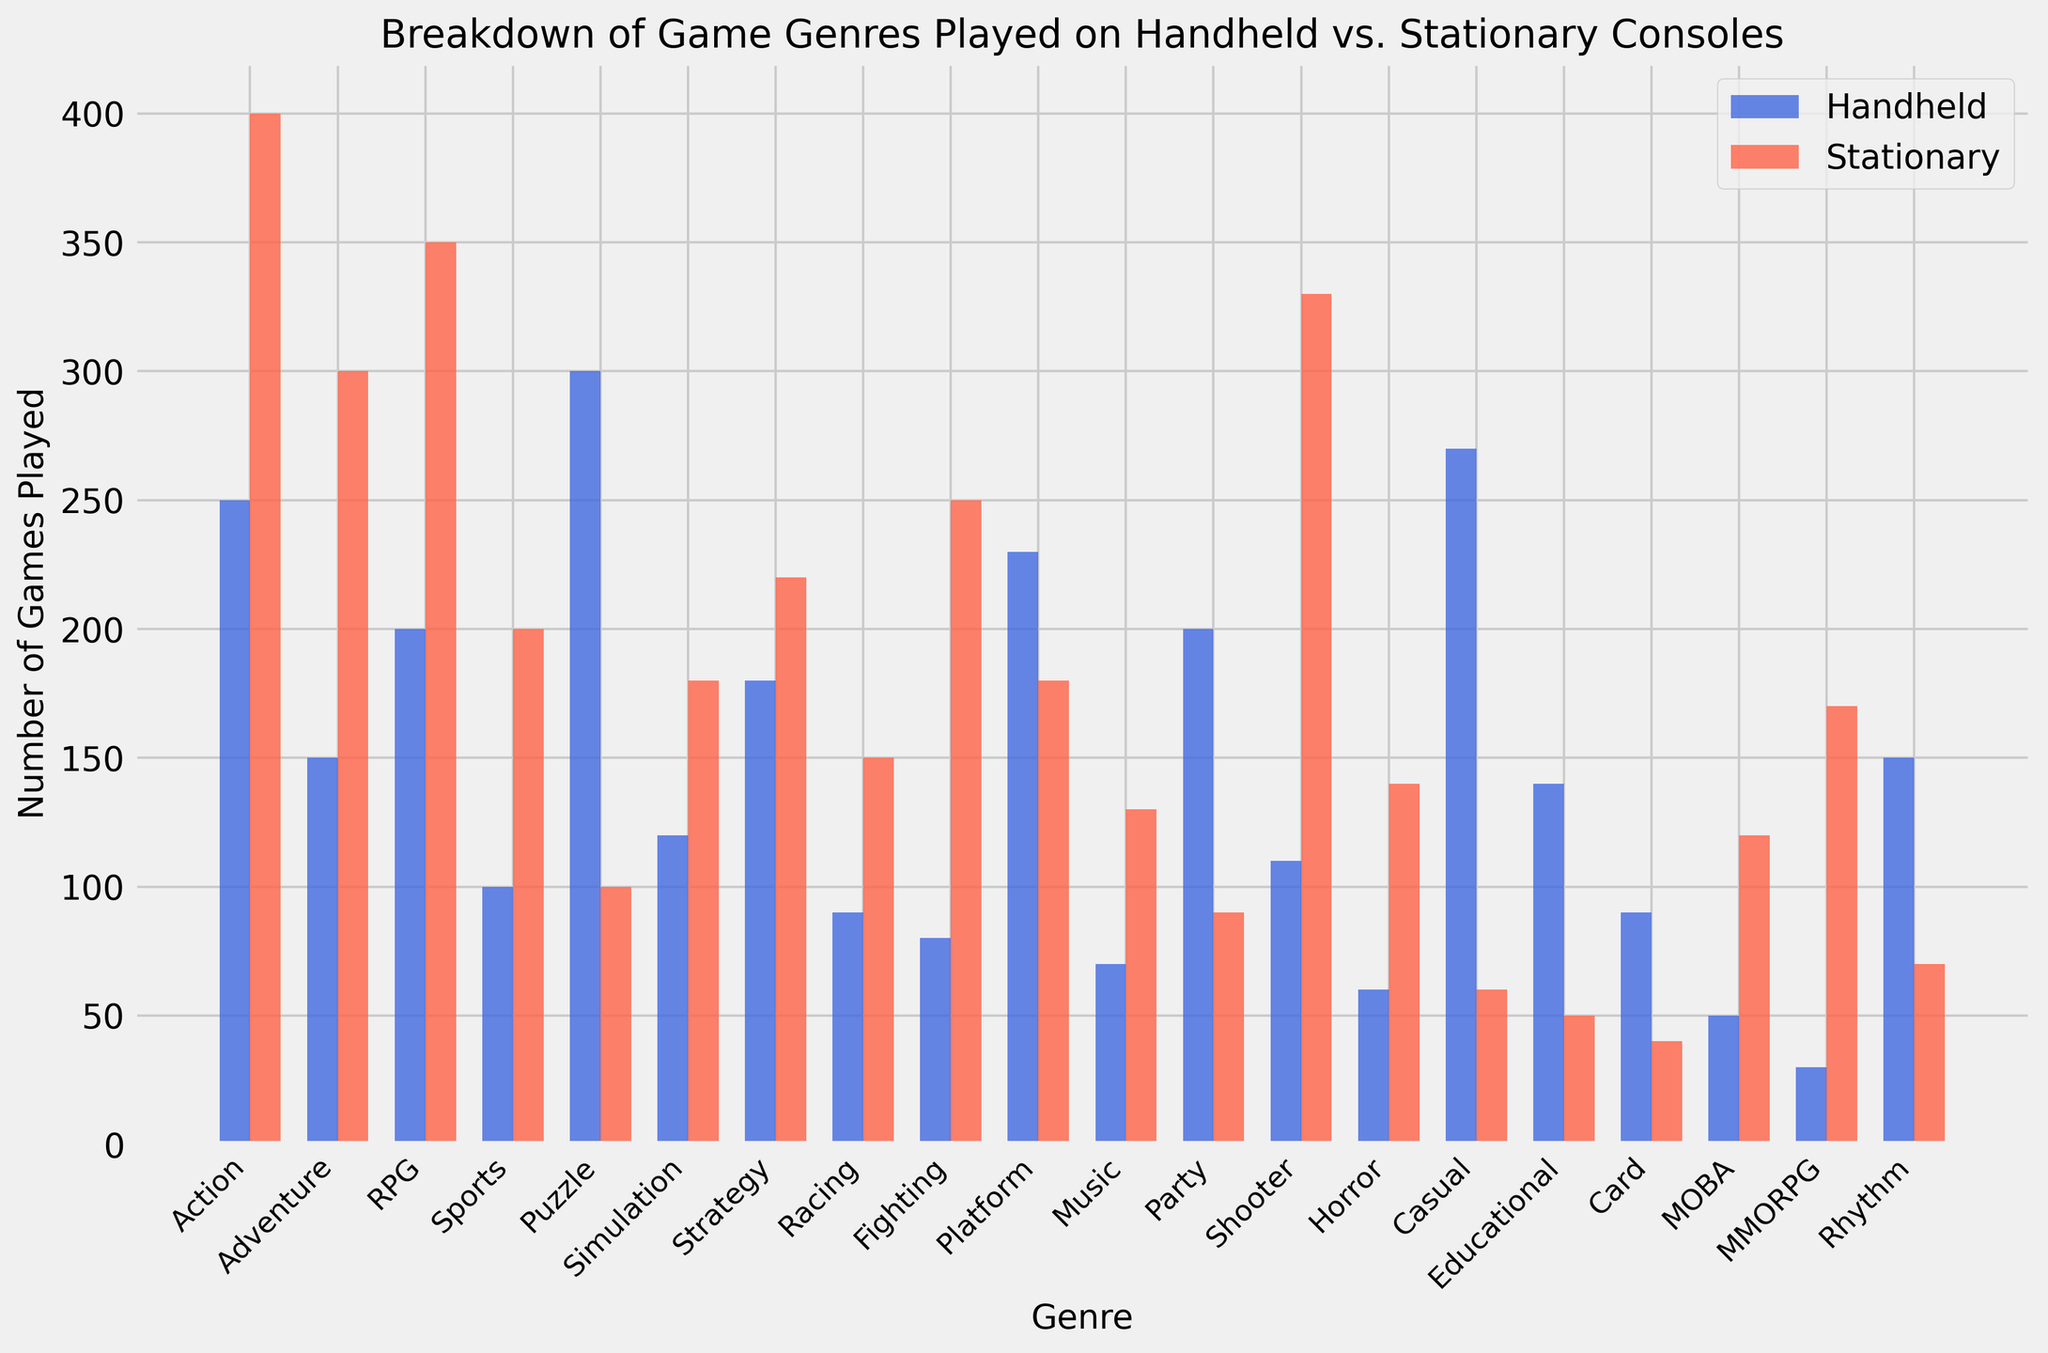Which genre has the highest number of games played on handheld consoles? The genre with the highest number of games played on handheld consoles is identified by the tallest blue bar. The Puzzle genre has the highest blue bar.
Answer: Puzzle Which genre has the lowest number of games played on stationary consoles? The genre with the lowest number of games played on stationary consoles is identified by the shortest red bar. The Card genre has the shortest red bar.
Answer: Card Which genre shows a greater number of games played on handheld consoles compared to stationary consoles? Comparing the heights of the bars for each genre, the genres where the blue bar is taller than the red bar are identified. The Puzzle and Casual genres have significantly taller blue bars compared to their red bars.
Answer: Puzzle, Casual How many more RPG games are played on stationary consoles compared to handheld consoles? The number of RPG games played on stationary consoles is 350, and on handheld consoles is 200. The difference is calculated as 350 - 200 = 150.
Answer: 150 Calculate the total number of sports and racing games played on both consoles combined. The total number of sports games is the sum of games on both consoles (100 + 200) and the total number of racing games is (90 + 150). Adding these totals: (100 + 200) + (90 + 150) = 540.
Answer: 540 How many genres have more than 200 games played on handheld consoles? We count the number of blue bars that are higher than 200 on the Y-axis. The genres are: Action, Puzzle, Platform, Casual, Party.
Answer: 5 What is the average number of Adventure games played across both consoles? The number of Adventure games played on handheld is 150, and on stationary is 300. The average is calculated as (150 + 300) / 2 = 225.
Answer: 225 Which genre has a significantly higher number of games on stationary consoles compared to handheld consoles? We compare the heights of the bars for each genre and look for those with a much taller red bar compared to the blue bar. The Adventure and Fighting genres show a significant difference, with taller red bars.
Answer: Adventure, Fighting 